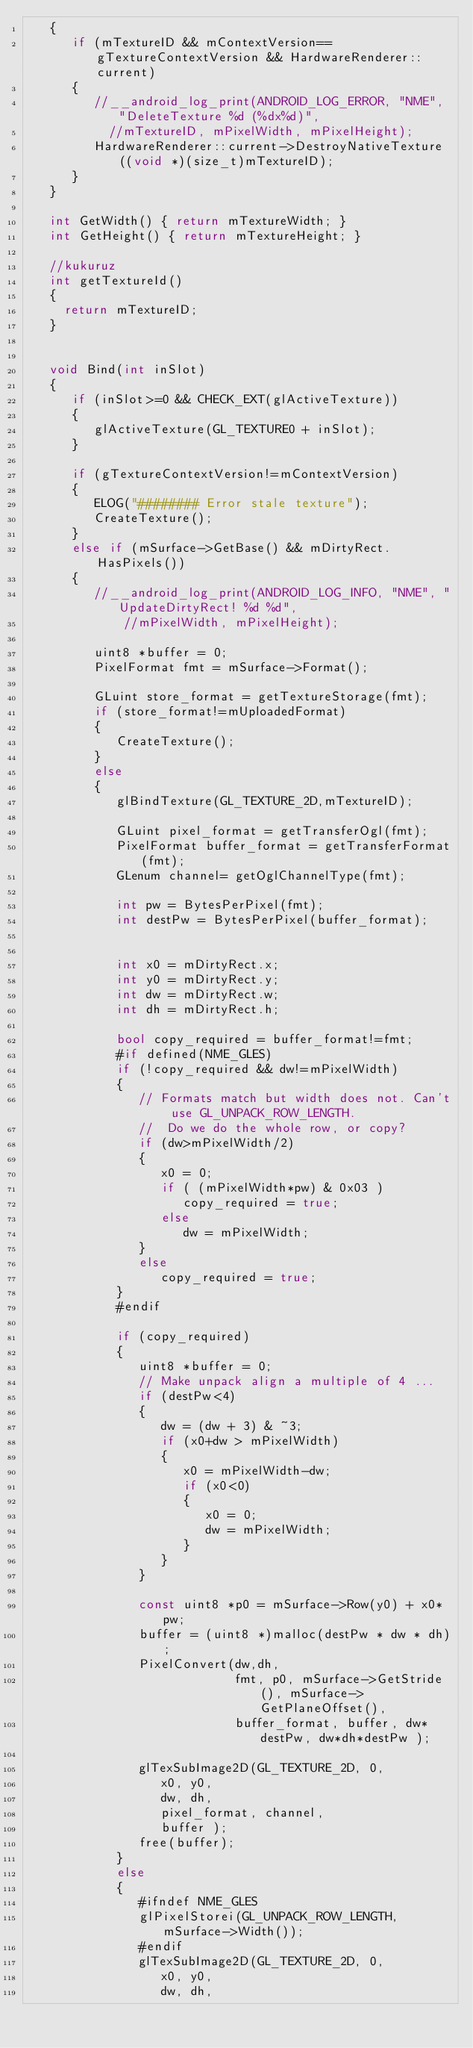Convert code to text. <code><loc_0><loc_0><loc_500><loc_500><_C++_>   {
      if (mTextureID && mContextVersion==gTextureContextVersion && HardwareRenderer::current)
      {
         //__android_log_print(ANDROID_LOG_ERROR, "NME", "DeleteTexture %d (%dx%d)",
           //mTextureID, mPixelWidth, mPixelHeight);
         HardwareRenderer::current->DestroyNativeTexture((void *)(size_t)mTextureID);
      }
   }

   int GetWidth() { return mTextureWidth; }
   int GetHeight() { return mTextureHeight; }
   
   //kukuruz
   int getTextureId()
   {
	   return mTextureID;
   }


   void Bind(int inSlot)
   {
      if (inSlot>=0 && CHECK_EXT(glActiveTexture))
      {
         glActiveTexture(GL_TEXTURE0 + inSlot);
      }

      if (gTextureContextVersion!=mContextVersion)
      {
         ELOG("######## Error stale texture");
         CreateTexture();
      }
      else if (mSurface->GetBase() && mDirtyRect.HasPixels())
      {
         //__android_log_print(ANDROID_LOG_INFO, "NME", "UpdateDirtyRect! %d %d",
             //mPixelWidth, mPixelHeight);

         uint8 *buffer = 0;
         PixelFormat fmt = mSurface->Format();

         GLuint store_format = getTextureStorage(fmt);
         if (store_format!=mUploadedFormat)
         {
            CreateTexture();
         }
         else
         {
            glBindTexture(GL_TEXTURE_2D,mTextureID);

            GLuint pixel_format = getTransferOgl(fmt);
            PixelFormat buffer_format = getTransferFormat(fmt);
            GLenum channel= getOglChannelType(fmt);

            int pw = BytesPerPixel(fmt);
            int destPw = BytesPerPixel(buffer_format);


            int x0 = mDirtyRect.x;
            int y0 = mDirtyRect.y;
            int dw = mDirtyRect.w;
            int dh = mDirtyRect.h;

            bool copy_required = buffer_format!=fmt;
            #if defined(NME_GLES)
            if (!copy_required && dw!=mPixelWidth)
            {
               // Formats match but width does not. Can't use GL_UNPACK_ROW_LENGTH.
               //  Do we do the whole row, or copy?
               if (dw>mPixelWidth/2)
               {
                  x0 = 0;
                  if ( (mPixelWidth*pw) & 0x03 )
                     copy_required = true;
                  else
                     dw = mPixelWidth;
               }
               else
                  copy_required = true;
            }
            #endif

            if (copy_required)
            {
               uint8 *buffer = 0;
               // Make unpack align a multiple of 4 ...
               if (destPw<4)
               {
                  dw = (dw + 3) & ~3;
                  if (x0+dw > mPixelWidth)
                  {
                     x0 = mPixelWidth-dw;
                     if (x0<0)
                     {
                        x0 = 0;
                        dw = mPixelWidth;
                     }
                  }
               }

               const uint8 *p0 = mSurface->Row(y0) + x0*pw;
               buffer = (uint8 *)malloc(destPw * dw * dh);
               PixelConvert(dw,dh,
                            fmt, p0, mSurface->GetStride(), mSurface->GetPlaneOffset(),
                            buffer_format, buffer, dw*destPw, dw*dh*destPw );

               glTexSubImage2D(GL_TEXTURE_2D, 0,
                  x0, y0,
                  dw, dh, 
                  pixel_format, channel,
                  buffer );
               free(buffer);
            }
            else
            {
               #ifndef NME_GLES
               glPixelStorei(GL_UNPACK_ROW_LENGTH, mSurface->Width());
               #endif
               glTexSubImage2D(GL_TEXTURE_2D, 0,
                  x0, y0,
                  dw, dh,</code> 